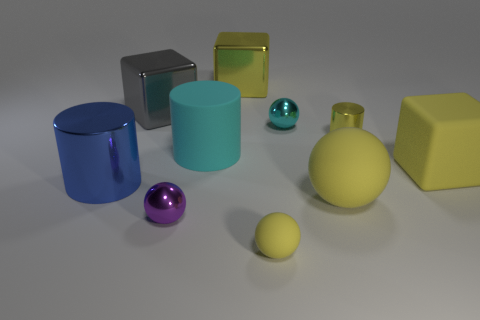How many objects are small purple rubber cylinders or tiny purple shiny things?
Give a very brief answer. 1. There is a small object that is behind the small yellow ball and in front of the small yellow cylinder; what shape is it?
Offer a terse response. Sphere. Does the big blue metallic object have the same shape as the small yellow thing in front of the purple thing?
Offer a very short reply. No. There is a gray cube; are there any tiny shiny things on the left side of it?
Make the answer very short. No. What material is the cylinder that is the same color as the tiny matte thing?
Make the answer very short. Metal. What number of cubes are cyan matte things or rubber things?
Give a very brief answer. 1. Do the purple object and the small rubber thing have the same shape?
Keep it short and to the point. Yes. There is a cylinder right of the tiny cyan metal object; how big is it?
Your response must be concise. Small. Is there a metal cylinder that has the same color as the rubber cylinder?
Give a very brief answer. No. Does the sphere that is behind the matte cube have the same size as the gray thing?
Give a very brief answer. No. 